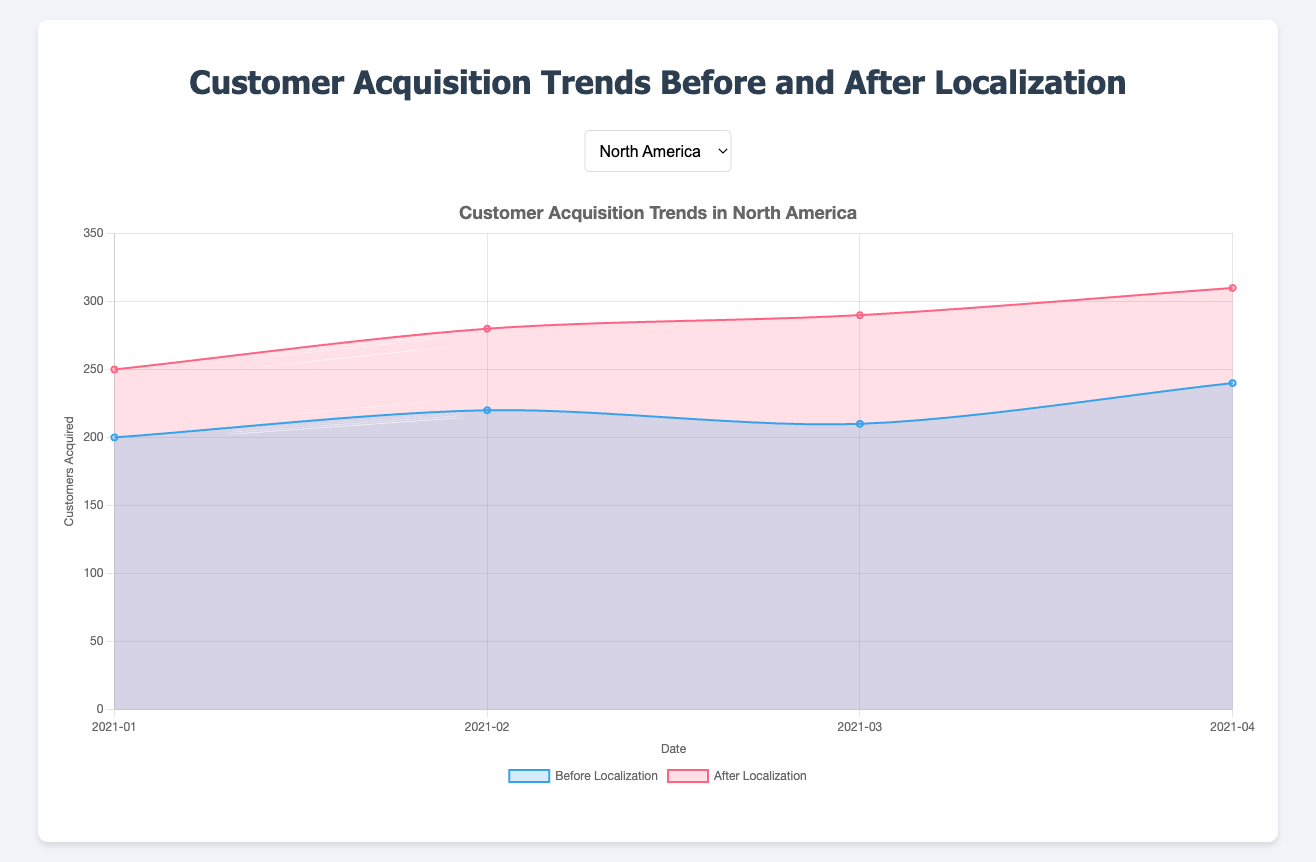What is the title of the figure? The title of the figure is clearly displayed at the top. It states "Customer Acquisition Trends Before and After Localization".
Answer: Customer Acquisition Trends Before and After Localization How does the number of customers acquired in North America after localization in April 2021 compare to that in March 2021? To compare the numbers, look at the "After Localization" data points for March and April 2021 in North America. In March, it is 290, and in April, it is 310. The number increased.
Answer: Increased How many more customers were acquired in Asia in February 2021 after localization compared to before localization? For February 2021 in Asia, the "Before Localization" number is 230 and the "After Localization" number is 320. Subtract the before number from the after number: 320 - 230 = 90.
Answer: 90 What is the average number of customers acquired in Europe after localization over the four months? To find the average, sum the after localization numbers for Europe: 220 + 240 + 260 + 280 = 1000. Then divide by 4 months: 1000 / 4 = 250.
Answer: 250 Which region showed the highest increase in customers acquired after localization in April 2021? Compare the increases in April 2021 by subtracting the "Before Localization" numbers from the "After Localization" numbers for each region. The increases are:
- North America: 310 - 240 = 70
- Europe: 280 - 210 = 70
- Asia: 360 - 260 = 100
- South America: 230 - 180 = 50
Asia showed the highest increase of 100.
Answer: Asia How did customer acquisition in South America change from January to April 2021 before localization? Look at the "Before Localization" data for South America from January to April 2021: January is 150, April is 180. The number increased.
Answer: Increased What is the trend in customer acquisition before and after localization in North America from January to April 2021? For North America, observe the trend lines for before and after localization from January to April 2021. Both lines show an upward trend, with the after localization line consistently above the before localization line.
Answer: Upward trend for both In which month did Europe see the smallest difference between customers acquired before and after localization? Calculate the differences for each month in Europe:
- January: 220 - 180 = 40
- February: 240 - 190 = 50
- March: 260 - 200 = 60
- April: 280 - 210 = 70
The smallest difference is in January, with a value of 40.
Answer: January How much did customer acquisition increase in Asia from February to March 2021 after localization? Look at the "After Localization" numbers for February and March 2021 in Asia: February is 320, March is 340. The increase is 340 - 320 = 20.
Answer: 20 